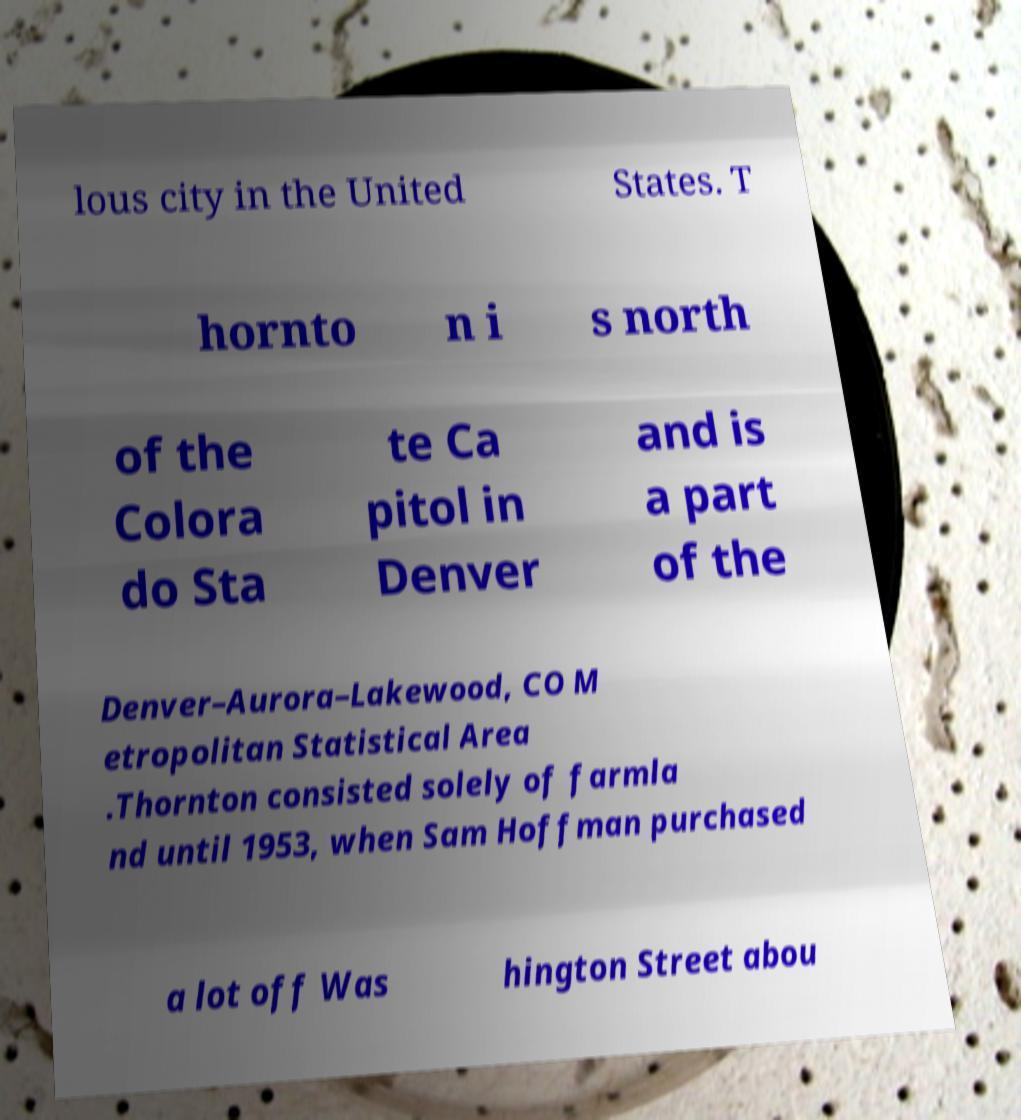Please read and relay the text visible in this image. What does it say? lous city in the United States. T hornto n i s north of the Colora do Sta te Ca pitol in Denver and is a part of the Denver–Aurora–Lakewood, CO M etropolitan Statistical Area .Thornton consisted solely of farmla nd until 1953, when Sam Hoffman purchased a lot off Was hington Street abou 